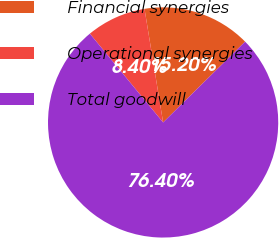<chart> <loc_0><loc_0><loc_500><loc_500><pie_chart><fcel>Financial synergies<fcel>Operational synergies<fcel>Total goodwill<nl><fcel>15.2%<fcel>8.4%<fcel>76.41%<nl></chart> 